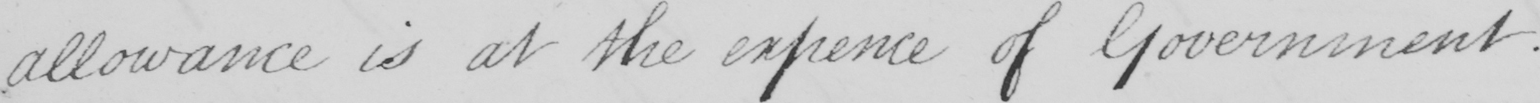Transcribe the text shown in this historical manuscript line. allowance is at the expence of Government . 